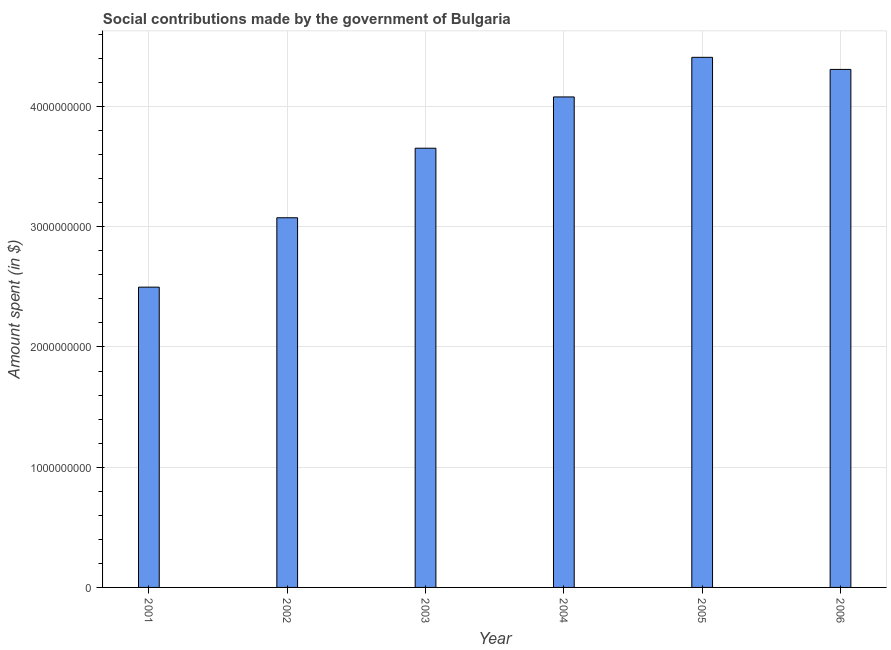Does the graph contain any zero values?
Your answer should be compact. No. What is the title of the graph?
Make the answer very short. Social contributions made by the government of Bulgaria. What is the label or title of the Y-axis?
Give a very brief answer. Amount spent (in $). What is the amount spent in making social contributions in 2006?
Offer a terse response. 4.31e+09. Across all years, what is the maximum amount spent in making social contributions?
Ensure brevity in your answer.  4.41e+09. Across all years, what is the minimum amount spent in making social contributions?
Your answer should be compact. 2.50e+09. In which year was the amount spent in making social contributions maximum?
Ensure brevity in your answer.  2005. What is the sum of the amount spent in making social contributions?
Provide a short and direct response. 2.20e+1. What is the difference between the amount spent in making social contributions in 2001 and 2003?
Offer a terse response. -1.16e+09. What is the average amount spent in making social contributions per year?
Give a very brief answer. 3.67e+09. What is the median amount spent in making social contributions?
Provide a succinct answer. 3.87e+09. Do a majority of the years between 2003 and 2006 (inclusive) have amount spent in making social contributions greater than 1000000000 $?
Your response must be concise. Yes. What is the ratio of the amount spent in making social contributions in 2003 to that in 2005?
Make the answer very short. 0.83. What is the difference between the highest and the second highest amount spent in making social contributions?
Give a very brief answer. 1.01e+08. Is the sum of the amount spent in making social contributions in 2001 and 2002 greater than the maximum amount spent in making social contributions across all years?
Offer a terse response. Yes. What is the difference between the highest and the lowest amount spent in making social contributions?
Ensure brevity in your answer.  1.91e+09. How many bars are there?
Your answer should be compact. 6. What is the difference between two consecutive major ticks on the Y-axis?
Your answer should be very brief. 1.00e+09. Are the values on the major ticks of Y-axis written in scientific E-notation?
Ensure brevity in your answer.  No. What is the Amount spent (in $) in 2001?
Provide a short and direct response. 2.50e+09. What is the Amount spent (in $) of 2002?
Give a very brief answer. 3.08e+09. What is the Amount spent (in $) in 2003?
Ensure brevity in your answer.  3.65e+09. What is the Amount spent (in $) of 2004?
Offer a very short reply. 4.08e+09. What is the Amount spent (in $) of 2005?
Make the answer very short. 4.41e+09. What is the Amount spent (in $) of 2006?
Give a very brief answer. 4.31e+09. What is the difference between the Amount spent (in $) in 2001 and 2002?
Your response must be concise. -5.77e+08. What is the difference between the Amount spent (in $) in 2001 and 2003?
Give a very brief answer. -1.16e+09. What is the difference between the Amount spent (in $) in 2001 and 2004?
Your answer should be compact. -1.58e+09. What is the difference between the Amount spent (in $) in 2001 and 2005?
Ensure brevity in your answer.  -1.91e+09. What is the difference between the Amount spent (in $) in 2001 and 2006?
Your response must be concise. -1.81e+09. What is the difference between the Amount spent (in $) in 2002 and 2003?
Provide a succinct answer. -5.78e+08. What is the difference between the Amount spent (in $) in 2002 and 2004?
Your answer should be compact. -1.01e+09. What is the difference between the Amount spent (in $) in 2002 and 2005?
Make the answer very short. -1.33e+09. What is the difference between the Amount spent (in $) in 2002 and 2006?
Your answer should be compact. -1.23e+09. What is the difference between the Amount spent (in $) in 2003 and 2004?
Make the answer very short. -4.27e+08. What is the difference between the Amount spent (in $) in 2003 and 2005?
Offer a terse response. -7.56e+08. What is the difference between the Amount spent (in $) in 2003 and 2006?
Provide a succinct answer. -6.55e+08. What is the difference between the Amount spent (in $) in 2004 and 2005?
Keep it short and to the point. -3.29e+08. What is the difference between the Amount spent (in $) in 2004 and 2006?
Your answer should be very brief. -2.29e+08. What is the difference between the Amount spent (in $) in 2005 and 2006?
Provide a short and direct response. 1.01e+08. What is the ratio of the Amount spent (in $) in 2001 to that in 2002?
Your answer should be very brief. 0.81. What is the ratio of the Amount spent (in $) in 2001 to that in 2003?
Keep it short and to the point. 0.68. What is the ratio of the Amount spent (in $) in 2001 to that in 2004?
Make the answer very short. 0.61. What is the ratio of the Amount spent (in $) in 2001 to that in 2005?
Provide a succinct answer. 0.57. What is the ratio of the Amount spent (in $) in 2001 to that in 2006?
Your response must be concise. 0.58. What is the ratio of the Amount spent (in $) in 2002 to that in 2003?
Give a very brief answer. 0.84. What is the ratio of the Amount spent (in $) in 2002 to that in 2004?
Offer a very short reply. 0.75. What is the ratio of the Amount spent (in $) in 2002 to that in 2005?
Provide a short and direct response. 0.7. What is the ratio of the Amount spent (in $) in 2002 to that in 2006?
Keep it short and to the point. 0.71. What is the ratio of the Amount spent (in $) in 2003 to that in 2004?
Keep it short and to the point. 0.9. What is the ratio of the Amount spent (in $) in 2003 to that in 2005?
Make the answer very short. 0.83. What is the ratio of the Amount spent (in $) in 2003 to that in 2006?
Give a very brief answer. 0.85. What is the ratio of the Amount spent (in $) in 2004 to that in 2005?
Make the answer very short. 0.93. What is the ratio of the Amount spent (in $) in 2004 to that in 2006?
Provide a short and direct response. 0.95. What is the ratio of the Amount spent (in $) in 2005 to that in 2006?
Give a very brief answer. 1.02. 